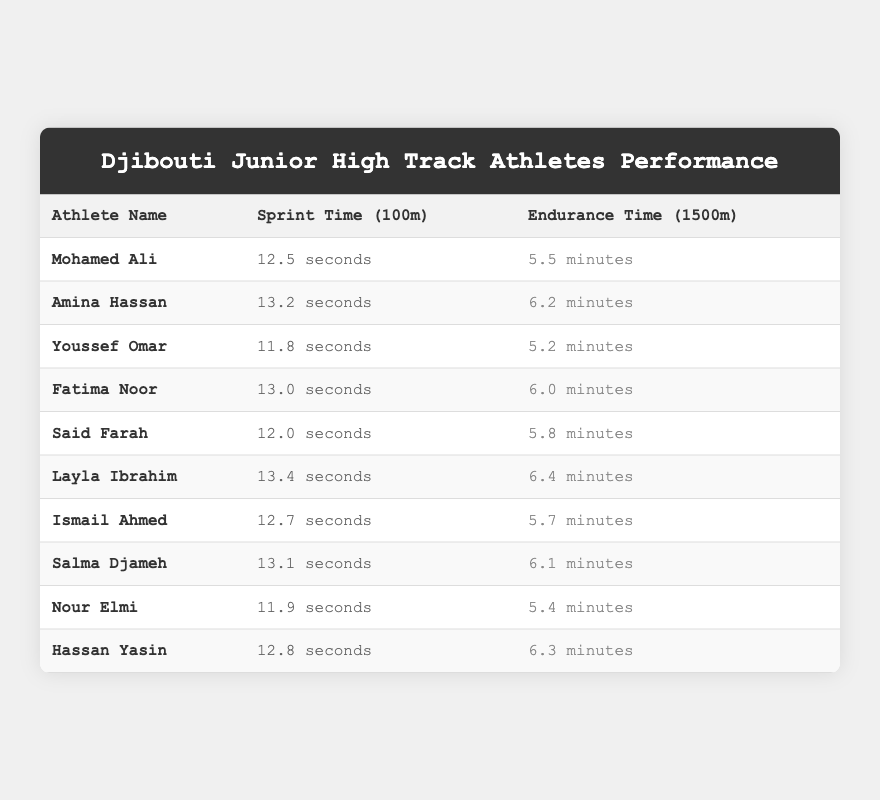What is the sprint time of Youssef Omar? The table shows that Youssef Omar has a sprint time of 11.8 seconds for the 100m.
Answer: 11.8 seconds Who has the fastest sprint time among the athletes? By comparing the sprint times in the table, Youssef Omar's 11.8 seconds is the fastest time listed.
Answer: Youssef Omar How many athletes have a sprint time of more than 13 seconds? The table lists Amina Hassan, Fatima Noor, Layla Ibrahim, and Salma Djameh with sprint times over 13 seconds. Therefore, there are 4 athletes.
Answer: 4 What is the average endurance time for all the athletes? Adding all the endurance times: 5.5 + 6.2 + 5.2 + 6.0 + 5.8 + 6.4 + 5.7 + 6.1 + 5.4 + 6.3 = 61.6 minutes. Dividing by 10 athletes gives an average of 61.6 / 10 = 6.16 minutes.
Answer: 6.16 minutes Which athlete has the slowest endurance time? Looking through the endurance times, Layla Ibrahim has the highest time of 6.4 minutes, making it the slowest.
Answer: Layla Ibrahim Is there any athlete with a sprint time lower than 12 seconds? Yes, the table shows Youssef Omar (11.8 seconds) and Nour Elmi (11.9 seconds) both have sprint times under 12 seconds.
Answer: Yes If we consider Mohamed Ali and Ismail Ahmed, who has the better overall performance based on both sprint and endurance times? Mohamed Ali has a sprint time of 12.5 seconds and an endurance time of 5.5 minutes, while Ismail Ahmed has a sprint time of 12.7 seconds and an endurance time of 5.7 minutes. Comparing the sprint times, Mohamed is faster, and he is faster in endurance as well. Therefore, Mohamed Ali performs better overall.
Answer: Mohamed Ali What is the difference in sprint times between Fatima Noor and Said Farah? Fatima Noor has a sprint time of 13.0 seconds and Said Farah has 12.0 seconds. The difference is 13.0 - 12.0 = 1.0 seconds.
Answer: 1.0 seconds Do any athletes have similar sprint and endurance times? By reviewing the table, Ismail Ahmed has a sprint time of 12.7 seconds and endurance time of 5.7 minutes, while Said Farah has a sprint time of 12.0 seconds and endurance time of 5.8 minutes. These values are fairly similar but not identical. Thus, the answer is no.
Answer: No Which athlete improved their sprint time the most compared to their endurance time? Comparing the sprint and endurance times for all athletes reveals that Youssef Omar's sprint time (11.8 seconds) compared to his endurance time (5.2 minutes) shows the largest relative improvement.
Answer: Youssef Omar 